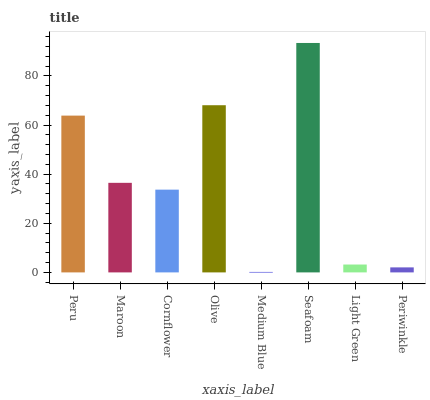Is Medium Blue the minimum?
Answer yes or no. Yes. Is Seafoam the maximum?
Answer yes or no. Yes. Is Maroon the minimum?
Answer yes or no. No. Is Maroon the maximum?
Answer yes or no. No. Is Peru greater than Maroon?
Answer yes or no. Yes. Is Maroon less than Peru?
Answer yes or no. Yes. Is Maroon greater than Peru?
Answer yes or no. No. Is Peru less than Maroon?
Answer yes or no. No. Is Maroon the high median?
Answer yes or no. Yes. Is Cornflower the low median?
Answer yes or no. Yes. Is Periwinkle the high median?
Answer yes or no. No. Is Periwinkle the low median?
Answer yes or no. No. 